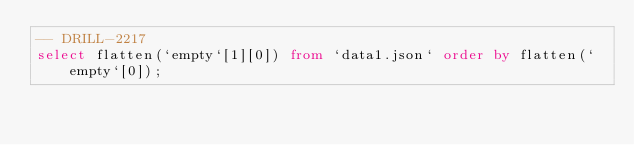Convert code to text. <code><loc_0><loc_0><loc_500><loc_500><_SQL_>-- DRILL-2217
select flatten(`empty`[1][0]) from `data1.json` order by flatten(`empty`[0]);
</code> 